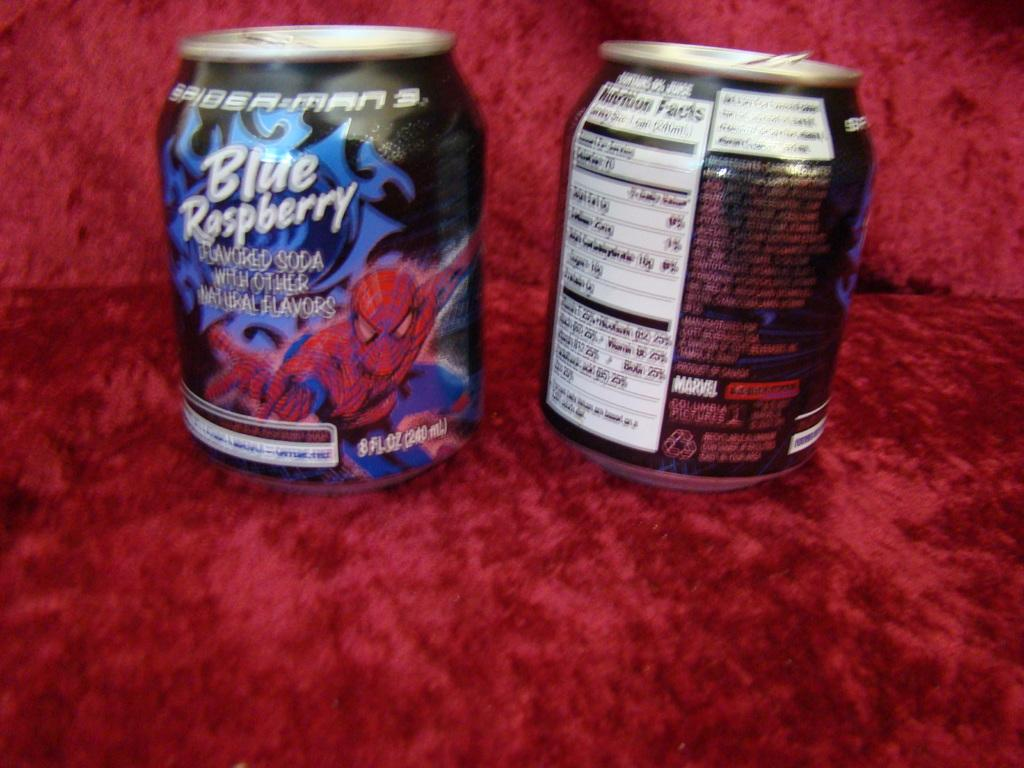<image>
Describe the image concisely. A couple of small cans of Blue Raspberry Soda sitting on red velvet. 